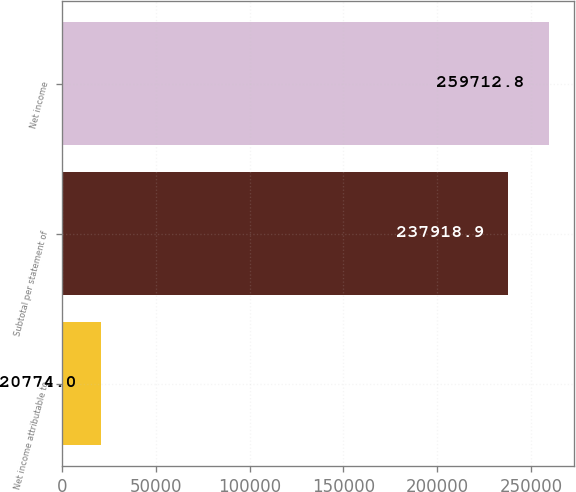Convert chart. <chart><loc_0><loc_0><loc_500><loc_500><bar_chart><fcel>Net income attributable to<fcel>Subtotal per statement of<fcel>Net income<nl><fcel>20774<fcel>237919<fcel>259713<nl></chart> 